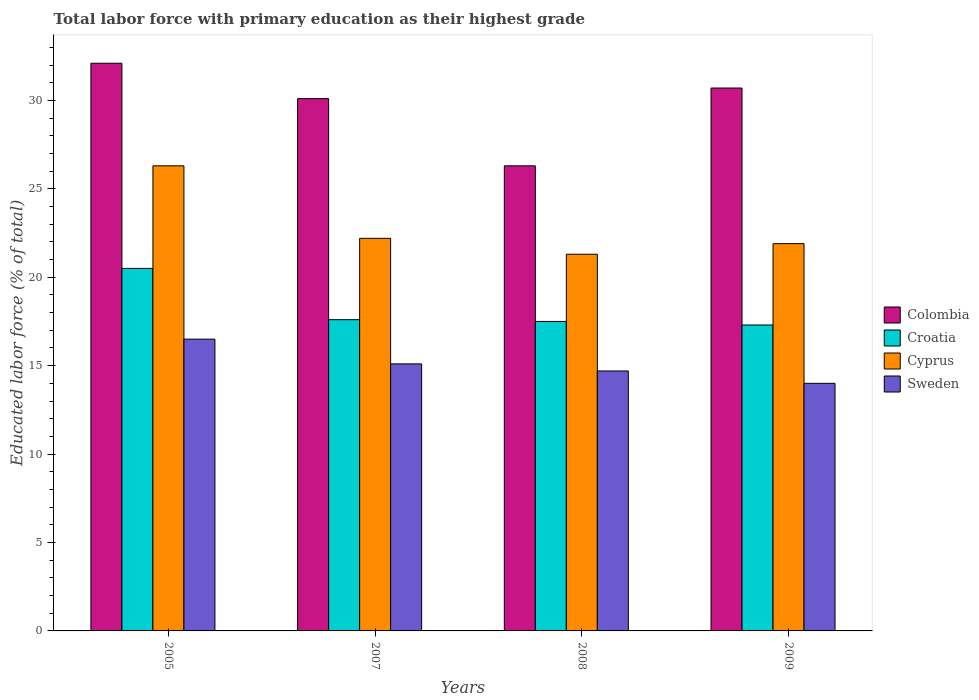How many groups of bars are there?
Offer a very short reply. 4. How many bars are there on the 4th tick from the left?
Offer a terse response. 4. What is the label of the 2nd group of bars from the left?
Ensure brevity in your answer.  2007. What is the percentage of total labor force with primary education in Colombia in 2007?
Provide a short and direct response. 30.1. Across all years, what is the minimum percentage of total labor force with primary education in Colombia?
Offer a terse response. 26.3. In which year was the percentage of total labor force with primary education in Cyprus maximum?
Your response must be concise. 2005. In which year was the percentage of total labor force with primary education in Colombia minimum?
Give a very brief answer. 2008. What is the total percentage of total labor force with primary education in Cyprus in the graph?
Offer a very short reply. 91.7. What is the difference between the percentage of total labor force with primary education in Cyprus in 2007 and the percentage of total labor force with primary education in Sweden in 2008?
Your answer should be compact. 7.5. What is the average percentage of total labor force with primary education in Cyprus per year?
Your answer should be compact. 22.92. In the year 2007, what is the difference between the percentage of total labor force with primary education in Sweden and percentage of total labor force with primary education in Cyprus?
Your response must be concise. -7.1. In how many years, is the percentage of total labor force with primary education in Sweden greater than 19 %?
Give a very brief answer. 0. What is the ratio of the percentage of total labor force with primary education in Cyprus in 2005 to that in 2009?
Offer a very short reply. 1.2. What is the difference between the highest and the second highest percentage of total labor force with primary education in Colombia?
Provide a succinct answer. 1.4. What does the 4th bar from the left in 2007 represents?
Keep it short and to the point. Sweden. What does the 4th bar from the right in 2008 represents?
Give a very brief answer. Colombia. How many bars are there?
Make the answer very short. 16. How many years are there in the graph?
Provide a succinct answer. 4. What is the difference between two consecutive major ticks on the Y-axis?
Give a very brief answer. 5. Are the values on the major ticks of Y-axis written in scientific E-notation?
Make the answer very short. No. Does the graph contain any zero values?
Make the answer very short. No. How many legend labels are there?
Your response must be concise. 4. What is the title of the graph?
Keep it short and to the point. Total labor force with primary education as their highest grade. What is the label or title of the X-axis?
Give a very brief answer. Years. What is the label or title of the Y-axis?
Provide a succinct answer. Educated labor force (% of total). What is the Educated labor force (% of total) in Colombia in 2005?
Provide a short and direct response. 32.1. What is the Educated labor force (% of total) in Cyprus in 2005?
Provide a short and direct response. 26.3. What is the Educated labor force (% of total) in Sweden in 2005?
Your response must be concise. 16.5. What is the Educated labor force (% of total) in Colombia in 2007?
Offer a terse response. 30.1. What is the Educated labor force (% of total) in Croatia in 2007?
Provide a short and direct response. 17.6. What is the Educated labor force (% of total) in Cyprus in 2007?
Keep it short and to the point. 22.2. What is the Educated labor force (% of total) of Sweden in 2007?
Make the answer very short. 15.1. What is the Educated labor force (% of total) of Colombia in 2008?
Offer a very short reply. 26.3. What is the Educated labor force (% of total) in Croatia in 2008?
Your answer should be compact. 17.5. What is the Educated labor force (% of total) of Cyprus in 2008?
Offer a very short reply. 21.3. What is the Educated labor force (% of total) of Sweden in 2008?
Your answer should be very brief. 14.7. What is the Educated labor force (% of total) in Colombia in 2009?
Give a very brief answer. 30.7. What is the Educated labor force (% of total) of Croatia in 2009?
Offer a very short reply. 17.3. What is the Educated labor force (% of total) of Cyprus in 2009?
Offer a terse response. 21.9. What is the Educated labor force (% of total) in Sweden in 2009?
Make the answer very short. 14. Across all years, what is the maximum Educated labor force (% of total) of Colombia?
Keep it short and to the point. 32.1. Across all years, what is the maximum Educated labor force (% of total) of Croatia?
Make the answer very short. 20.5. Across all years, what is the maximum Educated labor force (% of total) in Cyprus?
Offer a terse response. 26.3. Across all years, what is the minimum Educated labor force (% of total) of Colombia?
Provide a succinct answer. 26.3. Across all years, what is the minimum Educated labor force (% of total) in Croatia?
Your answer should be very brief. 17.3. Across all years, what is the minimum Educated labor force (% of total) in Cyprus?
Offer a very short reply. 21.3. Across all years, what is the minimum Educated labor force (% of total) of Sweden?
Your answer should be very brief. 14. What is the total Educated labor force (% of total) in Colombia in the graph?
Offer a terse response. 119.2. What is the total Educated labor force (% of total) of Croatia in the graph?
Ensure brevity in your answer.  72.9. What is the total Educated labor force (% of total) of Cyprus in the graph?
Offer a terse response. 91.7. What is the total Educated labor force (% of total) in Sweden in the graph?
Your answer should be very brief. 60.3. What is the difference between the Educated labor force (% of total) in Croatia in 2005 and that in 2007?
Your answer should be very brief. 2.9. What is the difference between the Educated labor force (% of total) in Colombia in 2005 and that in 2009?
Provide a short and direct response. 1.4. What is the difference between the Educated labor force (% of total) of Cyprus in 2005 and that in 2009?
Your response must be concise. 4.4. What is the difference between the Educated labor force (% of total) of Sweden in 2005 and that in 2009?
Offer a terse response. 2.5. What is the difference between the Educated labor force (% of total) of Cyprus in 2007 and that in 2008?
Offer a very short reply. 0.9. What is the difference between the Educated labor force (% of total) of Colombia in 2007 and that in 2009?
Offer a terse response. -0.6. What is the difference between the Educated labor force (% of total) of Croatia in 2007 and that in 2009?
Ensure brevity in your answer.  0.3. What is the difference between the Educated labor force (% of total) in Croatia in 2008 and that in 2009?
Give a very brief answer. 0.2. What is the difference between the Educated labor force (% of total) of Colombia in 2005 and the Educated labor force (% of total) of Croatia in 2007?
Make the answer very short. 14.5. What is the difference between the Educated labor force (% of total) of Colombia in 2005 and the Educated labor force (% of total) of Cyprus in 2007?
Make the answer very short. 9.9. What is the difference between the Educated labor force (% of total) in Colombia in 2005 and the Educated labor force (% of total) in Sweden in 2007?
Offer a terse response. 17. What is the difference between the Educated labor force (% of total) of Cyprus in 2005 and the Educated labor force (% of total) of Sweden in 2007?
Your answer should be very brief. 11.2. What is the difference between the Educated labor force (% of total) of Colombia in 2005 and the Educated labor force (% of total) of Croatia in 2008?
Offer a very short reply. 14.6. What is the difference between the Educated labor force (% of total) of Colombia in 2005 and the Educated labor force (% of total) of Cyprus in 2008?
Give a very brief answer. 10.8. What is the difference between the Educated labor force (% of total) in Croatia in 2005 and the Educated labor force (% of total) in Cyprus in 2009?
Make the answer very short. -1.4. What is the difference between the Educated labor force (% of total) in Croatia in 2005 and the Educated labor force (% of total) in Sweden in 2009?
Your answer should be very brief. 6.5. What is the difference between the Educated labor force (% of total) of Colombia in 2007 and the Educated labor force (% of total) of Croatia in 2008?
Your answer should be compact. 12.6. What is the difference between the Educated labor force (% of total) of Colombia in 2007 and the Educated labor force (% of total) of Cyprus in 2008?
Offer a very short reply. 8.8. What is the difference between the Educated labor force (% of total) of Croatia in 2007 and the Educated labor force (% of total) of Sweden in 2008?
Offer a terse response. 2.9. What is the difference between the Educated labor force (% of total) in Cyprus in 2007 and the Educated labor force (% of total) in Sweden in 2008?
Give a very brief answer. 7.5. What is the difference between the Educated labor force (% of total) in Cyprus in 2007 and the Educated labor force (% of total) in Sweden in 2009?
Your response must be concise. 8.2. What is the difference between the Educated labor force (% of total) in Colombia in 2008 and the Educated labor force (% of total) in Croatia in 2009?
Make the answer very short. 9. What is the difference between the Educated labor force (% of total) in Colombia in 2008 and the Educated labor force (% of total) in Cyprus in 2009?
Your answer should be compact. 4.4. What is the difference between the Educated labor force (% of total) in Colombia in 2008 and the Educated labor force (% of total) in Sweden in 2009?
Your response must be concise. 12.3. What is the difference between the Educated labor force (% of total) in Croatia in 2008 and the Educated labor force (% of total) in Cyprus in 2009?
Give a very brief answer. -4.4. What is the difference between the Educated labor force (% of total) in Cyprus in 2008 and the Educated labor force (% of total) in Sweden in 2009?
Keep it short and to the point. 7.3. What is the average Educated labor force (% of total) of Colombia per year?
Your response must be concise. 29.8. What is the average Educated labor force (% of total) in Croatia per year?
Offer a very short reply. 18.23. What is the average Educated labor force (% of total) of Cyprus per year?
Give a very brief answer. 22.93. What is the average Educated labor force (% of total) in Sweden per year?
Your answer should be very brief. 15.07. In the year 2005, what is the difference between the Educated labor force (% of total) in Colombia and Educated labor force (% of total) in Cyprus?
Offer a terse response. 5.8. In the year 2005, what is the difference between the Educated labor force (% of total) of Cyprus and Educated labor force (% of total) of Sweden?
Make the answer very short. 9.8. In the year 2007, what is the difference between the Educated labor force (% of total) in Colombia and Educated labor force (% of total) in Croatia?
Provide a short and direct response. 12.5. In the year 2007, what is the difference between the Educated labor force (% of total) in Colombia and Educated labor force (% of total) in Cyprus?
Your response must be concise. 7.9. In the year 2007, what is the difference between the Educated labor force (% of total) in Colombia and Educated labor force (% of total) in Sweden?
Your answer should be very brief. 15. In the year 2007, what is the difference between the Educated labor force (% of total) of Croatia and Educated labor force (% of total) of Cyprus?
Your response must be concise. -4.6. In the year 2007, what is the difference between the Educated labor force (% of total) of Croatia and Educated labor force (% of total) of Sweden?
Ensure brevity in your answer.  2.5. In the year 2007, what is the difference between the Educated labor force (% of total) of Cyprus and Educated labor force (% of total) of Sweden?
Offer a very short reply. 7.1. In the year 2008, what is the difference between the Educated labor force (% of total) in Colombia and Educated labor force (% of total) in Croatia?
Make the answer very short. 8.8. In the year 2008, what is the difference between the Educated labor force (% of total) of Colombia and Educated labor force (% of total) of Cyprus?
Keep it short and to the point. 5. In the year 2008, what is the difference between the Educated labor force (% of total) of Colombia and Educated labor force (% of total) of Sweden?
Your answer should be very brief. 11.6. In the year 2008, what is the difference between the Educated labor force (% of total) in Croatia and Educated labor force (% of total) in Cyprus?
Provide a succinct answer. -3.8. In the year 2008, what is the difference between the Educated labor force (% of total) of Croatia and Educated labor force (% of total) of Sweden?
Your answer should be very brief. 2.8. In the year 2009, what is the difference between the Educated labor force (% of total) of Colombia and Educated labor force (% of total) of Cyprus?
Give a very brief answer. 8.8. In the year 2009, what is the difference between the Educated labor force (% of total) of Colombia and Educated labor force (% of total) of Sweden?
Give a very brief answer. 16.7. In the year 2009, what is the difference between the Educated labor force (% of total) in Croatia and Educated labor force (% of total) in Cyprus?
Provide a short and direct response. -4.6. In the year 2009, what is the difference between the Educated labor force (% of total) in Croatia and Educated labor force (% of total) in Sweden?
Provide a short and direct response. 3.3. What is the ratio of the Educated labor force (% of total) in Colombia in 2005 to that in 2007?
Ensure brevity in your answer.  1.07. What is the ratio of the Educated labor force (% of total) in Croatia in 2005 to that in 2007?
Keep it short and to the point. 1.16. What is the ratio of the Educated labor force (% of total) of Cyprus in 2005 to that in 2007?
Offer a very short reply. 1.18. What is the ratio of the Educated labor force (% of total) of Sweden in 2005 to that in 2007?
Your answer should be compact. 1.09. What is the ratio of the Educated labor force (% of total) in Colombia in 2005 to that in 2008?
Provide a succinct answer. 1.22. What is the ratio of the Educated labor force (% of total) in Croatia in 2005 to that in 2008?
Offer a very short reply. 1.17. What is the ratio of the Educated labor force (% of total) in Cyprus in 2005 to that in 2008?
Make the answer very short. 1.23. What is the ratio of the Educated labor force (% of total) in Sweden in 2005 to that in 2008?
Your response must be concise. 1.12. What is the ratio of the Educated labor force (% of total) in Colombia in 2005 to that in 2009?
Give a very brief answer. 1.05. What is the ratio of the Educated labor force (% of total) in Croatia in 2005 to that in 2009?
Make the answer very short. 1.19. What is the ratio of the Educated labor force (% of total) of Cyprus in 2005 to that in 2009?
Provide a succinct answer. 1.2. What is the ratio of the Educated labor force (% of total) in Sweden in 2005 to that in 2009?
Provide a succinct answer. 1.18. What is the ratio of the Educated labor force (% of total) in Colombia in 2007 to that in 2008?
Give a very brief answer. 1.14. What is the ratio of the Educated labor force (% of total) in Croatia in 2007 to that in 2008?
Ensure brevity in your answer.  1.01. What is the ratio of the Educated labor force (% of total) in Cyprus in 2007 to that in 2008?
Offer a very short reply. 1.04. What is the ratio of the Educated labor force (% of total) of Sweden in 2007 to that in 2008?
Your answer should be very brief. 1.03. What is the ratio of the Educated labor force (% of total) in Colombia in 2007 to that in 2009?
Your response must be concise. 0.98. What is the ratio of the Educated labor force (% of total) of Croatia in 2007 to that in 2009?
Offer a very short reply. 1.02. What is the ratio of the Educated labor force (% of total) in Cyprus in 2007 to that in 2009?
Offer a terse response. 1.01. What is the ratio of the Educated labor force (% of total) in Sweden in 2007 to that in 2009?
Offer a very short reply. 1.08. What is the ratio of the Educated labor force (% of total) in Colombia in 2008 to that in 2009?
Provide a succinct answer. 0.86. What is the ratio of the Educated labor force (% of total) in Croatia in 2008 to that in 2009?
Offer a terse response. 1.01. What is the ratio of the Educated labor force (% of total) in Cyprus in 2008 to that in 2009?
Your answer should be very brief. 0.97. What is the ratio of the Educated labor force (% of total) in Sweden in 2008 to that in 2009?
Ensure brevity in your answer.  1.05. What is the difference between the highest and the second highest Educated labor force (% of total) of Colombia?
Offer a terse response. 1.4. What is the difference between the highest and the second highest Educated labor force (% of total) in Croatia?
Offer a terse response. 2.9. What is the difference between the highest and the second highest Educated labor force (% of total) of Sweden?
Provide a succinct answer. 1.4. What is the difference between the highest and the lowest Educated labor force (% of total) in Croatia?
Provide a succinct answer. 3.2. 